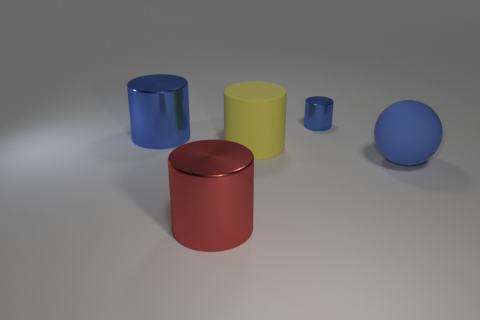Is the shape of the matte object to the left of the small blue metal object the same as the metal thing in front of the large yellow matte thing?
Provide a succinct answer. Yes. Are there any large red objects that have the same material as the tiny cylinder?
Your answer should be very brief. Yes. Is the material of the blue cylinder in front of the small shiny object the same as the red cylinder?
Keep it short and to the point. Yes. Are there more large blue objects in front of the big blue ball than large red shiny cylinders that are on the right side of the large red cylinder?
Keep it short and to the point. No. What is the color of the sphere that is the same size as the yellow cylinder?
Offer a terse response. Blue. Is there a large rubber thing of the same color as the tiny object?
Your response must be concise. Yes. Is the color of the big metallic cylinder that is in front of the blue sphere the same as the big cylinder that is behind the big yellow thing?
Ensure brevity in your answer.  No. There is a blue cylinder in front of the small object; what is its material?
Your answer should be very brief. Metal. The big thing that is made of the same material as the ball is what color?
Offer a terse response. Yellow. How many yellow rubber blocks are the same size as the blue rubber sphere?
Ensure brevity in your answer.  0. 